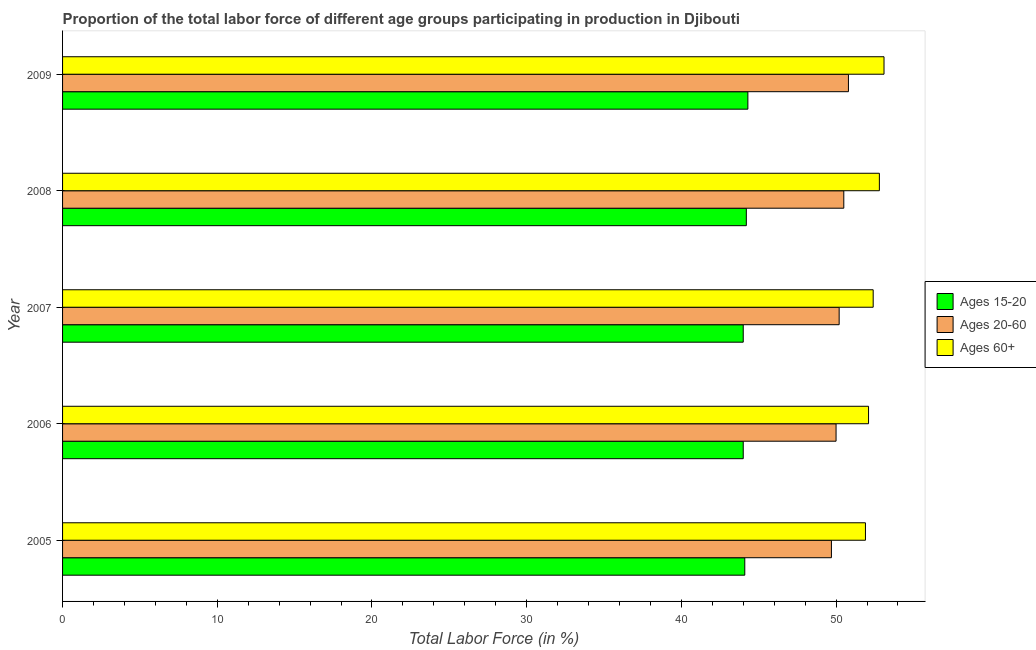How many different coloured bars are there?
Give a very brief answer. 3. How many groups of bars are there?
Make the answer very short. 5. Are the number of bars on each tick of the Y-axis equal?
Make the answer very short. Yes. What is the percentage of labor force within the age group 20-60 in 2006?
Your answer should be very brief. 50. Across all years, what is the maximum percentage of labor force within the age group 15-20?
Your answer should be very brief. 44.3. Across all years, what is the minimum percentage of labor force within the age group 15-20?
Provide a short and direct response. 44. In which year was the percentage of labor force within the age group 20-60 maximum?
Keep it short and to the point. 2009. What is the total percentage of labor force within the age group 15-20 in the graph?
Ensure brevity in your answer.  220.6. What is the difference between the percentage of labor force within the age group 15-20 in 2005 and that in 2006?
Your answer should be compact. 0.1. What is the difference between the percentage of labor force above age 60 in 2007 and the percentage of labor force within the age group 15-20 in 2009?
Offer a very short reply. 8.1. What is the average percentage of labor force within the age group 20-60 per year?
Make the answer very short. 50.24. In how many years, is the percentage of labor force within the age group 15-20 greater than 20 %?
Provide a succinct answer. 5. What is the ratio of the percentage of labor force within the age group 20-60 in 2005 to that in 2008?
Provide a succinct answer. 0.98. Is the percentage of labor force above age 60 in 2005 less than that in 2008?
Ensure brevity in your answer.  Yes. Is the difference between the percentage of labor force within the age group 15-20 in 2005 and 2009 greater than the difference between the percentage of labor force above age 60 in 2005 and 2009?
Provide a short and direct response. Yes. What is the difference between the highest and the second highest percentage of labor force above age 60?
Your answer should be very brief. 0.3. In how many years, is the percentage of labor force within the age group 15-20 greater than the average percentage of labor force within the age group 15-20 taken over all years?
Offer a terse response. 2. Is the sum of the percentage of labor force within the age group 15-20 in 2005 and 2006 greater than the maximum percentage of labor force within the age group 20-60 across all years?
Your response must be concise. Yes. What does the 2nd bar from the top in 2005 represents?
Give a very brief answer. Ages 20-60. What does the 3rd bar from the bottom in 2007 represents?
Give a very brief answer. Ages 60+. How many bars are there?
Provide a succinct answer. 15. How many years are there in the graph?
Ensure brevity in your answer.  5. What is the difference between two consecutive major ticks on the X-axis?
Offer a terse response. 10. Does the graph contain any zero values?
Ensure brevity in your answer.  No. How many legend labels are there?
Your response must be concise. 3. How are the legend labels stacked?
Provide a succinct answer. Vertical. What is the title of the graph?
Your answer should be compact. Proportion of the total labor force of different age groups participating in production in Djibouti. What is the label or title of the X-axis?
Offer a terse response. Total Labor Force (in %). What is the Total Labor Force (in %) of Ages 15-20 in 2005?
Ensure brevity in your answer.  44.1. What is the Total Labor Force (in %) of Ages 20-60 in 2005?
Offer a very short reply. 49.7. What is the Total Labor Force (in %) in Ages 60+ in 2005?
Your response must be concise. 51.9. What is the Total Labor Force (in %) in Ages 60+ in 2006?
Ensure brevity in your answer.  52.1. What is the Total Labor Force (in %) in Ages 15-20 in 2007?
Offer a very short reply. 44. What is the Total Labor Force (in %) of Ages 20-60 in 2007?
Offer a very short reply. 50.2. What is the Total Labor Force (in %) in Ages 60+ in 2007?
Your answer should be very brief. 52.4. What is the Total Labor Force (in %) in Ages 15-20 in 2008?
Give a very brief answer. 44.2. What is the Total Labor Force (in %) in Ages 20-60 in 2008?
Ensure brevity in your answer.  50.5. What is the Total Labor Force (in %) of Ages 60+ in 2008?
Provide a short and direct response. 52.8. What is the Total Labor Force (in %) of Ages 15-20 in 2009?
Offer a terse response. 44.3. What is the Total Labor Force (in %) of Ages 20-60 in 2009?
Provide a short and direct response. 50.8. What is the Total Labor Force (in %) in Ages 60+ in 2009?
Your response must be concise. 53.1. Across all years, what is the maximum Total Labor Force (in %) in Ages 15-20?
Your answer should be compact. 44.3. Across all years, what is the maximum Total Labor Force (in %) in Ages 20-60?
Offer a very short reply. 50.8. Across all years, what is the maximum Total Labor Force (in %) of Ages 60+?
Provide a succinct answer. 53.1. Across all years, what is the minimum Total Labor Force (in %) of Ages 15-20?
Provide a short and direct response. 44. Across all years, what is the minimum Total Labor Force (in %) of Ages 20-60?
Your answer should be compact. 49.7. Across all years, what is the minimum Total Labor Force (in %) in Ages 60+?
Give a very brief answer. 51.9. What is the total Total Labor Force (in %) of Ages 15-20 in the graph?
Give a very brief answer. 220.6. What is the total Total Labor Force (in %) of Ages 20-60 in the graph?
Your answer should be very brief. 251.2. What is the total Total Labor Force (in %) of Ages 60+ in the graph?
Make the answer very short. 262.3. What is the difference between the Total Labor Force (in %) in Ages 60+ in 2005 and that in 2006?
Make the answer very short. -0.2. What is the difference between the Total Labor Force (in %) of Ages 15-20 in 2005 and that in 2007?
Keep it short and to the point. 0.1. What is the difference between the Total Labor Force (in %) of Ages 20-60 in 2005 and that in 2007?
Offer a terse response. -0.5. What is the difference between the Total Labor Force (in %) in Ages 60+ in 2005 and that in 2007?
Your answer should be very brief. -0.5. What is the difference between the Total Labor Force (in %) of Ages 15-20 in 2005 and that in 2008?
Make the answer very short. -0.1. What is the difference between the Total Labor Force (in %) in Ages 60+ in 2005 and that in 2008?
Give a very brief answer. -0.9. What is the difference between the Total Labor Force (in %) of Ages 20-60 in 2006 and that in 2007?
Your answer should be very brief. -0.2. What is the difference between the Total Labor Force (in %) of Ages 20-60 in 2006 and that in 2008?
Offer a very short reply. -0.5. What is the difference between the Total Labor Force (in %) in Ages 60+ in 2006 and that in 2008?
Give a very brief answer. -0.7. What is the difference between the Total Labor Force (in %) of Ages 15-20 in 2006 and that in 2009?
Ensure brevity in your answer.  -0.3. What is the difference between the Total Labor Force (in %) of Ages 20-60 in 2006 and that in 2009?
Give a very brief answer. -0.8. What is the difference between the Total Labor Force (in %) of Ages 60+ in 2006 and that in 2009?
Your response must be concise. -1. What is the difference between the Total Labor Force (in %) in Ages 15-20 in 2007 and that in 2008?
Provide a succinct answer. -0.2. What is the difference between the Total Labor Force (in %) in Ages 20-60 in 2007 and that in 2008?
Your answer should be very brief. -0.3. What is the difference between the Total Labor Force (in %) in Ages 60+ in 2007 and that in 2008?
Ensure brevity in your answer.  -0.4. What is the difference between the Total Labor Force (in %) of Ages 15-20 in 2007 and that in 2009?
Provide a short and direct response. -0.3. What is the difference between the Total Labor Force (in %) in Ages 20-60 in 2007 and that in 2009?
Make the answer very short. -0.6. What is the difference between the Total Labor Force (in %) in Ages 15-20 in 2005 and the Total Labor Force (in %) in Ages 60+ in 2006?
Keep it short and to the point. -8. What is the difference between the Total Labor Force (in %) in Ages 15-20 in 2005 and the Total Labor Force (in %) in Ages 20-60 in 2007?
Give a very brief answer. -6.1. What is the difference between the Total Labor Force (in %) in Ages 15-20 in 2005 and the Total Labor Force (in %) in Ages 60+ in 2008?
Your response must be concise. -8.7. What is the difference between the Total Labor Force (in %) in Ages 20-60 in 2005 and the Total Labor Force (in %) in Ages 60+ in 2009?
Provide a succinct answer. -3.4. What is the difference between the Total Labor Force (in %) of Ages 15-20 in 2006 and the Total Labor Force (in %) of Ages 20-60 in 2008?
Offer a very short reply. -6.5. What is the difference between the Total Labor Force (in %) in Ages 15-20 in 2006 and the Total Labor Force (in %) in Ages 60+ in 2008?
Give a very brief answer. -8.8. What is the difference between the Total Labor Force (in %) of Ages 20-60 in 2006 and the Total Labor Force (in %) of Ages 60+ in 2008?
Your response must be concise. -2.8. What is the difference between the Total Labor Force (in %) in Ages 15-20 in 2006 and the Total Labor Force (in %) in Ages 60+ in 2009?
Ensure brevity in your answer.  -9.1. What is the difference between the Total Labor Force (in %) in Ages 15-20 in 2007 and the Total Labor Force (in %) in Ages 20-60 in 2008?
Make the answer very short. -6.5. What is the difference between the Total Labor Force (in %) in Ages 15-20 in 2007 and the Total Labor Force (in %) in Ages 60+ in 2009?
Keep it short and to the point. -9.1. What is the difference between the Total Labor Force (in %) in Ages 20-60 in 2007 and the Total Labor Force (in %) in Ages 60+ in 2009?
Give a very brief answer. -2.9. What is the difference between the Total Labor Force (in %) of Ages 15-20 in 2008 and the Total Labor Force (in %) of Ages 20-60 in 2009?
Ensure brevity in your answer.  -6.6. What is the difference between the Total Labor Force (in %) in Ages 20-60 in 2008 and the Total Labor Force (in %) in Ages 60+ in 2009?
Ensure brevity in your answer.  -2.6. What is the average Total Labor Force (in %) of Ages 15-20 per year?
Provide a succinct answer. 44.12. What is the average Total Labor Force (in %) in Ages 20-60 per year?
Offer a very short reply. 50.24. What is the average Total Labor Force (in %) in Ages 60+ per year?
Keep it short and to the point. 52.46. In the year 2005, what is the difference between the Total Labor Force (in %) in Ages 15-20 and Total Labor Force (in %) in Ages 20-60?
Provide a succinct answer. -5.6. In the year 2006, what is the difference between the Total Labor Force (in %) of Ages 15-20 and Total Labor Force (in %) of Ages 20-60?
Offer a very short reply. -6. In the year 2006, what is the difference between the Total Labor Force (in %) of Ages 15-20 and Total Labor Force (in %) of Ages 60+?
Give a very brief answer. -8.1. In the year 2006, what is the difference between the Total Labor Force (in %) in Ages 20-60 and Total Labor Force (in %) in Ages 60+?
Your response must be concise. -2.1. In the year 2008, what is the difference between the Total Labor Force (in %) in Ages 15-20 and Total Labor Force (in %) in Ages 20-60?
Provide a succinct answer. -6.3. In the year 2008, what is the difference between the Total Labor Force (in %) of Ages 15-20 and Total Labor Force (in %) of Ages 60+?
Your answer should be compact. -8.6. In the year 2008, what is the difference between the Total Labor Force (in %) in Ages 20-60 and Total Labor Force (in %) in Ages 60+?
Ensure brevity in your answer.  -2.3. In the year 2009, what is the difference between the Total Labor Force (in %) of Ages 15-20 and Total Labor Force (in %) of Ages 20-60?
Your answer should be compact. -6.5. In the year 2009, what is the difference between the Total Labor Force (in %) in Ages 15-20 and Total Labor Force (in %) in Ages 60+?
Offer a very short reply. -8.8. What is the ratio of the Total Labor Force (in %) in Ages 15-20 in 2005 to that in 2006?
Your answer should be very brief. 1. What is the ratio of the Total Labor Force (in %) in Ages 15-20 in 2005 to that in 2007?
Keep it short and to the point. 1. What is the ratio of the Total Labor Force (in %) of Ages 20-60 in 2005 to that in 2007?
Offer a very short reply. 0.99. What is the ratio of the Total Labor Force (in %) in Ages 20-60 in 2005 to that in 2008?
Provide a short and direct response. 0.98. What is the ratio of the Total Labor Force (in %) in Ages 20-60 in 2005 to that in 2009?
Provide a succinct answer. 0.98. What is the ratio of the Total Labor Force (in %) of Ages 60+ in 2005 to that in 2009?
Your answer should be very brief. 0.98. What is the ratio of the Total Labor Force (in %) in Ages 20-60 in 2006 to that in 2007?
Provide a succinct answer. 1. What is the ratio of the Total Labor Force (in %) of Ages 60+ in 2006 to that in 2007?
Your response must be concise. 0.99. What is the ratio of the Total Labor Force (in %) of Ages 15-20 in 2006 to that in 2008?
Your answer should be compact. 1. What is the ratio of the Total Labor Force (in %) of Ages 60+ in 2006 to that in 2008?
Provide a succinct answer. 0.99. What is the ratio of the Total Labor Force (in %) in Ages 20-60 in 2006 to that in 2009?
Offer a terse response. 0.98. What is the ratio of the Total Labor Force (in %) of Ages 60+ in 2006 to that in 2009?
Ensure brevity in your answer.  0.98. What is the ratio of the Total Labor Force (in %) of Ages 15-20 in 2007 to that in 2008?
Your response must be concise. 1. What is the ratio of the Total Labor Force (in %) in Ages 15-20 in 2008 to that in 2009?
Provide a succinct answer. 1. What is the ratio of the Total Labor Force (in %) in Ages 20-60 in 2008 to that in 2009?
Offer a terse response. 0.99. What is the ratio of the Total Labor Force (in %) in Ages 60+ in 2008 to that in 2009?
Make the answer very short. 0.99. What is the difference between the highest and the second highest Total Labor Force (in %) in Ages 20-60?
Provide a succinct answer. 0.3. What is the difference between the highest and the second highest Total Labor Force (in %) in Ages 60+?
Provide a succinct answer. 0.3. What is the difference between the highest and the lowest Total Labor Force (in %) in Ages 60+?
Make the answer very short. 1.2. 